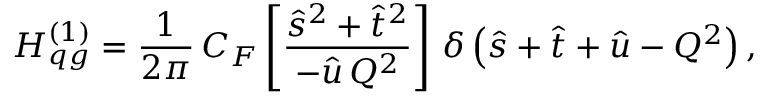<formula> <loc_0><loc_0><loc_500><loc_500>H _ { q g } ^ { ( 1 ) } = \frac { 1 } { 2 \pi } \, C _ { F } \left [ \frac { \hat { s } ^ { 2 } + \hat { t } ^ { 2 } } { - \hat { u } \, Q ^ { 2 } } \right ] \, \delta \left ( \hat { s } + \hat { t } + \hat { u } - Q ^ { 2 } \right ) ,</formula> 